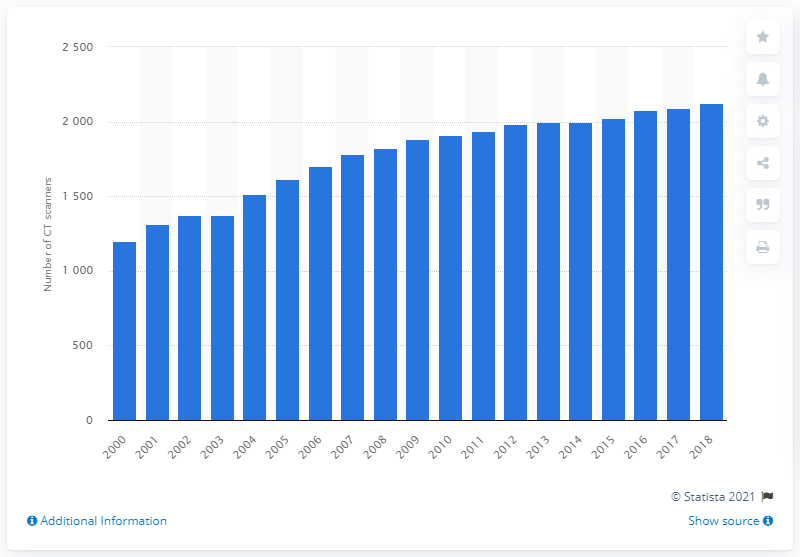Give some essential details in this illustration. In 2018, the number of CTS scanners in Italy was 2093. Since the year 2000, the number of computed tomography scanners in Italy has risen significantly. In 2000, there were 1,203 CT scanners in Italy. 